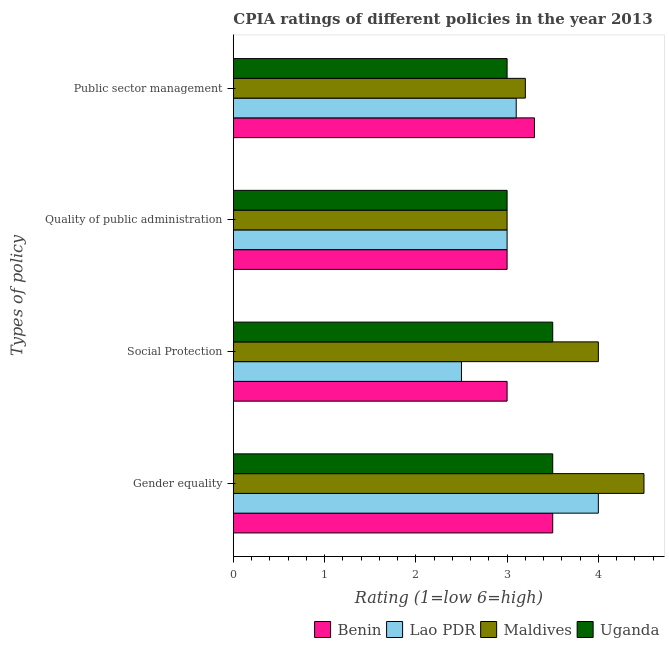How many bars are there on the 1st tick from the top?
Give a very brief answer. 4. How many bars are there on the 4th tick from the bottom?
Your answer should be compact. 4. What is the label of the 2nd group of bars from the top?
Ensure brevity in your answer.  Quality of public administration. What is the cpia rating of social protection in Uganda?
Give a very brief answer. 3.5. Across all countries, what is the minimum cpia rating of quality of public administration?
Provide a succinct answer. 3. In which country was the cpia rating of public sector management maximum?
Give a very brief answer. Benin. In which country was the cpia rating of public sector management minimum?
Provide a short and direct response. Uganda. What is the total cpia rating of public sector management in the graph?
Provide a succinct answer. 12.6. What is the difference between the cpia rating of gender equality in Lao PDR and that in Maldives?
Your response must be concise. -0.5. What is the difference between the cpia rating of public sector management in Benin and the cpia rating of quality of public administration in Uganda?
Your answer should be very brief. 0.3. What is the difference between the cpia rating of social protection and cpia rating of public sector management in Benin?
Provide a short and direct response. -0.3. In how many countries, is the cpia rating of public sector management greater than 1.2 ?
Keep it short and to the point. 4. What is the ratio of the cpia rating of gender equality in Maldives to that in Uganda?
Provide a succinct answer. 1.29. Is the cpia rating of public sector management in Lao PDR less than that in Maldives?
Keep it short and to the point. Yes. Is the sum of the cpia rating of public sector management in Maldives and Lao PDR greater than the maximum cpia rating of quality of public administration across all countries?
Your response must be concise. Yes. Is it the case that in every country, the sum of the cpia rating of social protection and cpia rating of gender equality is greater than the sum of cpia rating of public sector management and cpia rating of quality of public administration?
Your answer should be compact. Yes. What does the 3rd bar from the top in Gender equality represents?
Provide a short and direct response. Lao PDR. What does the 1st bar from the bottom in Quality of public administration represents?
Make the answer very short. Benin. How many bars are there?
Give a very brief answer. 16. Are all the bars in the graph horizontal?
Ensure brevity in your answer.  Yes. Does the graph contain grids?
Ensure brevity in your answer.  No. How many legend labels are there?
Your response must be concise. 4. What is the title of the graph?
Give a very brief answer. CPIA ratings of different policies in the year 2013. Does "World" appear as one of the legend labels in the graph?
Keep it short and to the point. No. What is the label or title of the Y-axis?
Make the answer very short. Types of policy. What is the Rating (1=low 6=high) in Lao PDR in Social Protection?
Give a very brief answer. 2.5. What is the Rating (1=low 6=high) in Maldives in Social Protection?
Provide a succinct answer. 4. What is the Rating (1=low 6=high) of Uganda in Social Protection?
Ensure brevity in your answer.  3.5. What is the Rating (1=low 6=high) in Benin in Quality of public administration?
Make the answer very short. 3. What is the Rating (1=low 6=high) in Maldives in Quality of public administration?
Provide a short and direct response. 3. What is the Rating (1=low 6=high) in Benin in Public sector management?
Your answer should be compact. 3.3. What is the Rating (1=low 6=high) of Maldives in Public sector management?
Your answer should be very brief. 3.2. Across all Types of policy, what is the maximum Rating (1=low 6=high) of Maldives?
Provide a succinct answer. 4.5. What is the total Rating (1=low 6=high) of Benin in the graph?
Provide a short and direct response. 12.8. What is the total Rating (1=low 6=high) in Maldives in the graph?
Give a very brief answer. 14.7. What is the total Rating (1=low 6=high) of Uganda in the graph?
Offer a terse response. 13. What is the difference between the Rating (1=low 6=high) in Maldives in Gender equality and that in Social Protection?
Give a very brief answer. 0.5. What is the difference between the Rating (1=low 6=high) of Uganda in Gender equality and that in Social Protection?
Provide a short and direct response. 0. What is the difference between the Rating (1=low 6=high) of Benin in Gender equality and that in Quality of public administration?
Give a very brief answer. 0.5. What is the difference between the Rating (1=low 6=high) of Lao PDR in Gender equality and that in Quality of public administration?
Give a very brief answer. 1. What is the difference between the Rating (1=low 6=high) in Maldives in Gender equality and that in Quality of public administration?
Provide a succinct answer. 1.5. What is the difference between the Rating (1=low 6=high) of Benin in Gender equality and that in Public sector management?
Your response must be concise. 0.2. What is the difference between the Rating (1=low 6=high) in Lao PDR in Gender equality and that in Public sector management?
Your answer should be compact. 0.9. What is the difference between the Rating (1=low 6=high) in Uganda in Gender equality and that in Public sector management?
Provide a succinct answer. 0.5. What is the difference between the Rating (1=low 6=high) of Benin in Social Protection and that in Quality of public administration?
Your answer should be compact. 0. What is the difference between the Rating (1=low 6=high) of Benin in Social Protection and that in Public sector management?
Give a very brief answer. -0.3. What is the difference between the Rating (1=low 6=high) in Lao PDR in Social Protection and that in Public sector management?
Provide a succinct answer. -0.6. What is the difference between the Rating (1=low 6=high) in Lao PDR in Quality of public administration and that in Public sector management?
Your answer should be compact. -0.1. What is the difference between the Rating (1=low 6=high) in Maldives in Quality of public administration and that in Public sector management?
Give a very brief answer. -0.2. What is the difference between the Rating (1=low 6=high) in Uganda in Quality of public administration and that in Public sector management?
Give a very brief answer. 0. What is the difference between the Rating (1=low 6=high) of Lao PDR in Gender equality and the Rating (1=low 6=high) of Maldives in Social Protection?
Keep it short and to the point. 0. What is the difference between the Rating (1=low 6=high) in Maldives in Gender equality and the Rating (1=low 6=high) in Uganda in Social Protection?
Ensure brevity in your answer.  1. What is the difference between the Rating (1=low 6=high) in Benin in Gender equality and the Rating (1=low 6=high) in Maldives in Quality of public administration?
Your response must be concise. 0.5. What is the difference between the Rating (1=low 6=high) of Benin in Gender equality and the Rating (1=low 6=high) of Uganda in Quality of public administration?
Your answer should be compact. 0.5. What is the difference between the Rating (1=low 6=high) in Lao PDR in Gender equality and the Rating (1=low 6=high) in Uganda in Quality of public administration?
Your response must be concise. 1. What is the difference between the Rating (1=low 6=high) of Benin in Gender equality and the Rating (1=low 6=high) of Maldives in Public sector management?
Provide a succinct answer. 0.3. What is the difference between the Rating (1=low 6=high) of Lao PDR in Gender equality and the Rating (1=low 6=high) of Maldives in Public sector management?
Your answer should be very brief. 0.8. What is the difference between the Rating (1=low 6=high) in Maldives in Gender equality and the Rating (1=low 6=high) in Uganda in Public sector management?
Ensure brevity in your answer.  1.5. What is the difference between the Rating (1=low 6=high) of Benin in Social Protection and the Rating (1=low 6=high) of Uganda in Quality of public administration?
Offer a terse response. 0. What is the difference between the Rating (1=low 6=high) in Lao PDR in Social Protection and the Rating (1=low 6=high) in Maldives in Quality of public administration?
Offer a very short reply. -0.5. What is the difference between the Rating (1=low 6=high) in Lao PDR in Social Protection and the Rating (1=low 6=high) in Maldives in Public sector management?
Ensure brevity in your answer.  -0.7. What is the difference between the Rating (1=low 6=high) of Maldives in Social Protection and the Rating (1=low 6=high) of Uganda in Public sector management?
Provide a short and direct response. 1. What is the difference between the Rating (1=low 6=high) of Benin in Quality of public administration and the Rating (1=low 6=high) of Uganda in Public sector management?
Offer a very short reply. 0. What is the average Rating (1=low 6=high) in Lao PDR per Types of policy?
Provide a short and direct response. 3.15. What is the average Rating (1=low 6=high) in Maldives per Types of policy?
Keep it short and to the point. 3.67. What is the average Rating (1=low 6=high) of Uganda per Types of policy?
Offer a terse response. 3.25. What is the difference between the Rating (1=low 6=high) in Benin and Rating (1=low 6=high) in Maldives in Gender equality?
Ensure brevity in your answer.  -1. What is the difference between the Rating (1=low 6=high) of Lao PDR and Rating (1=low 6=high) of Maldives in Gender equality?
Ensure brevity in your answer.  -0.5. What is the difference between the Rating (1=low 6=high) in Maldives and Rating (1=low 6=high) in Uganda in Gender equality?
Provide a short and direct response. 1. What is the difference between the Rating (1=low 6=high) of Benin and Rating (1=low 6=high) of Lao PDR in Social Protection?
Your answer should be compact. 0.5. What is the difference between the Rating (1=low 6=high) of Benin and Rating (1=low 6=high) of Maldives in Social Protection?
Keep it short and to the point. -1. What is the difference between the Rating (1=low 6=high) in Benin and Rating (1=low 6=high) in Uganda in Social Protection?
Keep it short and to the point. -0.5. What is the difference between the Rating (1=low 6=high) in Lao PDR and Rating (1=low 6=high) in Maldives in Social Protection?
Offer a very short reply. -1.5. What is the difference between the Rating (1=low 6=high) in Maldives and Rating (1=low 6=high) in Uganda in Social Protection?
Your response must be concise. 0.5. What is the difference between the Rating (1=low 6=high) of Benin and Rating (1=low 6=high) of Uganda in Quality of public administration?
Make the answer very short. 0. What is the difference between the Rating (1=low 6=high) of Maldives and Rating (1=low 6=high) of Uganda in Quality of public administration?
Make the answer very short. 0. What is the difference between the Rating (1=low 6=high) of Benin and Rating (1=low 6=high) of Maldives in Public sector management?
Make the answer very short. 0.1. What is the difference between the Rating (1=low 6=high) of Benin and Rating (1=low 6=high) of Uganda in Public sector management?
Provide a short and direct response. 0.3. What is the difference between the Rating (1=low 6=high) of Lao PDR and Rating (1=low 6=high) of Uganda in Public sector management?
Keep it short and to the point. 0.1. What is the ratio of the Rating (1=low 6=high) of Benin in Gender equality to that in Social Protection?
Give a very brief answer. 1.17. What is the ratio of the Rating (1=low 6=high) of Lao PDR in Gender equality to that in Social Protection?
Ensure brevity in your answer.  1.6. What is the ratio of the Rating (1=low 6=high) in Maldives in Gender equality to that in Social Protection?
Offer a very short reply. 1.12. What is the ratio of the Rating (1=low 6=high) in Benin in Gender equality to that in Public sector management?
Provide a short and direct response. 1.06. What is the ratio of the Rating (1=low 6=high) of Lao PDR in Gender equality to that in Public sector management?
Make the answer very short. 1.29. What is the ratio of the Rating (1=low 6=high) in Maldives in Gender equality to that in Public sector management?
Provide a succinct answer. 1.41. What is the ratio of the Rating (1=low 6=high) of Uganda in Gender equality to that in Public sector management?
Make the answer very short. 1.17. What is the ratio of the Rating (1=low 6=high) in Lao PDR in Social Protection to that in Quality of public administration?
Offer a terse response. 0.83. What is the ratio of the Rating (1=low 6=high) in Lao PDR in Social Protection to that in Public sector management?
Keep it short and to the point. 0.81. What is the ratio of the Rating (1=low 6=high) in Maldives in Social Protection to that in Public sector management?
Offer a very short reply. 1.25. What is the ratio of the Rating (1=low 6=high) in Uganda in Social Protection to that in Public sector management?
Provide a short and direct response. 1.17. What is the ratio of the Rating (1=low 6=high) in Lao PDR in Quality of public administration to that in Public sector management?
Give a very brief answer. 0.97. What is the ratio of the Rating (1=low 6=high) in Maldives in Quality of public administration to that in Public sector management?
Provide a succinct answer. 0.94. What is the ratio of the Rating (1=low 6=high) in Uganda in Quality of public administration to that in Public sector management?
Provide a succinct answer. 1. What is the difference between the highest and the second highest Rating (1=low 6=high) in Maldives?
Make the answer very short. 0.5. What is the difference between the highest and the second highest Rating (1=low 6=high) of Uganda?
Give a very brief answer. 0. What is the difference between the highest and the lowest Rating (1=low 6=high) of Maldives?
Ensure brevity in your answer.  1.5. 